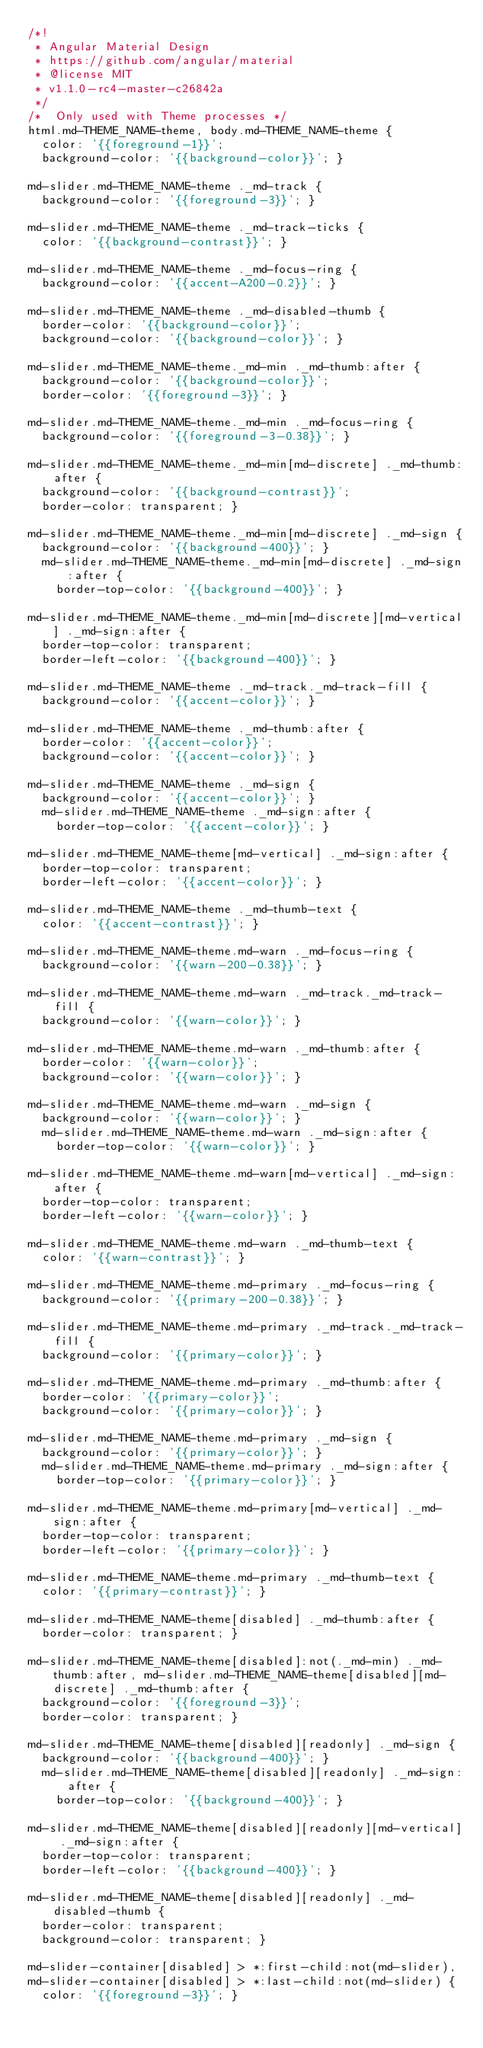<code> <loc_0><loc_0><loc_500><loc_500><_CSS_>/*!
 * Angular Material Design
 * https://github.com/angular/material
 * @license MIT
 * v1.1.0-rc4-master-c26842a
 */
/*  Only used with Theme processes */
html.md-THEME_NAME-theme, body.md-THEME_NAME-theme {
  color: '{{foreground-1}}';
  background-color: '{{background-color}}'; }

md-slider.md-THEME_NAME-theme ._md-track {
  background-color: '{{foreground-3}}'; }

md-slider.md-THEME_NAME-theme ._md-track-ticks {
  color: '{{background-contrast}}'; }

md-slider.md-THEME_NAME-theme ._md-focus-ring {
  background-color: '{{accent-A200-0.2}}'; }

md-slider.md-THEME_NAME-theme ._md-disabled-thumb {
  border-color: '{{background-color}}';
  background-color: '{{background-color}}'; }

md-slider.md-THEME_NAME-theme._md-min ._md-thumb:after {
  background-color: '{{background-color}}';
  border-color: '{{foreground-3}}'; }

md-slider.md-THEME_NAME-theme._md-min ._md-focus-ring {
  background-color: '{{foreground-3-0.38}}'; }

md-slider.md-THEME_NAME-theme._md-min[md-discrete] ._md-thumb:after {
  background-color: '{{background-contrast}}';
  border-color: transparent; }

md-slider.md-THEME_NAME-theme._md-min[md-discrete] ._md-sign {
  background-color: '{{background-400}}'; }
  md-slider.md-THEME_NAME-theme._md-min[md-discrete] ._md-sign:after {
    border-top-color: '{{background-400}}'; }

md-slider.md-THEME_NAME-theme._md-min[md-discrete][md-vertical] ._md-sign:after {
  border-top-color: transparent;
  border-left-color: '{{background-400}}'; }

md-slider.md-THEME_NAME-theme ._md-track._md-track-fill {
  background-color: '{{accent-color}}'; }

md-slider.md-THEME_NAME-theme ._md-thumb:after {
  border-color: '{{accent-color}}';
  background-color: '{{accent-color}}'; }

md-slider.md-THEME_NAME-theme ._md-sign {
  background-color: '{{accent-color}}'; }
  md-slider.md-THEME_NAME-theme ._md-sign:after {
    border-top-color: '{{accent-color}}'; }

md-slider.md-THEME_NAME-theme[md-vertical] ._md-sign:after {
  border-top-color: transparent;
  border-left-color: '{{accent-color}}'; }

md-slider.md-THEME_NAME-theme ._md-thumb-text {
  color: '{{accent-contrast}}'; }

md-slider.md-THEME_NAME-theme.md-warn ._md-focus-ring {
  background-color: '{{warn-200-0.38}}'; }

md-slider.md-THEME_NAME-theme.md-warn ._md-track._md-track-fill {
  background-color: '{{warn-color}}'; }

md-slider.md-THEME_NAME-theme.md-warn ._md-thumb:after {
  border-color: '{{warn-color}}';
  background-color: '{{warn-color}}'; }

md-slider.md-THEME_NAME-theme.md-warn ._md-sign {
  background-color: '{{warn-color}}'; }
  md-slider.md-THEME_NAME-theme.md-warn ._md-sign:after {
    border-top-color: '{{warn-color}}'; }

md-slider.md-THEME_NAME-theme.md-warn[md-vertical] ._md-sign:after {
  border-top-color: transparent;
  border-left-color: '{{warn-color}}'; }

md-slider.md-THEME_NAME-theme.md-warn ._md-thumb-text {
  color: '{{warn-contrast}}'; }

md-slider.md-THEME_NAME-theme.md-primary ._md-focus-ring {
  background-color: '{{primary-200-0.38}}'; }

md-slider.md-THEME_NAME-theme.md-primary ._md-track._md-track-fill {
  background-color: '{{primary-color}}'; }

md-slider.md-THEME_NAME-theme.md-primary ._md-thumb:after {
  border-color: '{{primary-color}}';
  background-color: '{{primary-color}}'; }

md-slider.md-THEME_NAME-theme.md-primary ._md-sign {
  background-color: '{{primary-color}}'; }
  md-slider.md-THEME_NAME-theme.md-primary ._md-sign:after {
    border-top-color: '{{primary-color}}'; }

md-slider.md-THEME_NAME-theme.md-primary[md-vertical] ._md-sign:after {
  border-top-color: transparent;
  border-left-color: '{{primary-color}}'; }

md-slider.md-THEME_NAME-theme.md-primary ._md-thumb-text {
  color: '{{primary-contrast}}'; }

md-slider.md-THEME_NAME-theme[disabled] ._md-thumb:after {
  border-color: transparent; }

md-slider.md-THEME_NAME-theme[disabled]:not(._md-min) ._md-thumb:after, md-slider.md-THEME_NAME-theme[disabled][md-discrete] ._md-thumb:after {
  background-color: '{{foreground-3}}';
  border-color: transparent; }

md-slider.md-THEME_NAME-theme[disabled][readonly] ._md-sign {
  background-color: '{{background-400}}'; }
  md-slider.md-THEME_NAME-theme[disabled][readonly] ._md-sign:after {
    border-top-color: '{{background-400}}'; }

md-slider.md-THEME_NAME-theme[disabled][readonly][md-vertical] ._md-sign:after {
  border-top-color: transparent;
  border-left-color: '{{background-400}}'; }

md-slider.md-THEME_NAME-theme[disabled][readonly] ._md-disabled-thumb {
  border-color: transparent;
  background-color: transparent; }

md-slider-container[disabled] > *:first-child:not(md-slider),
md-slider-container[disabled] > *:last-child:not(md-slider) {
  color: '{{foreground-3}}'; }
</code> 